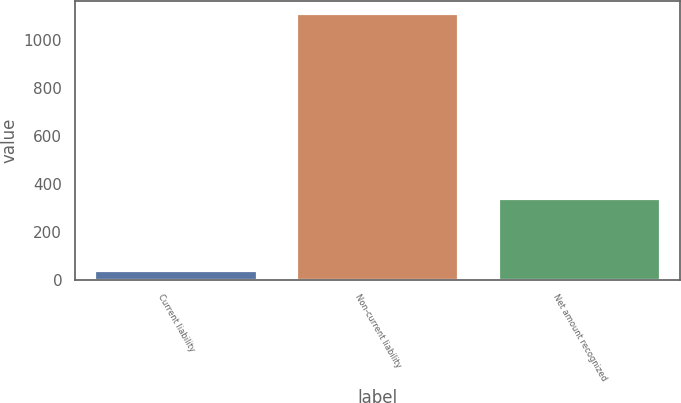Convert chart to OTSL. <chart><loc_0><loc_0><loc_500><loc_500><bar_chart><fcel>Current liability<fcel>Non-current liability<fcel>Net amount recognized<nl><fcel>37<fcel>1109<fcel>335<nl></chart> 